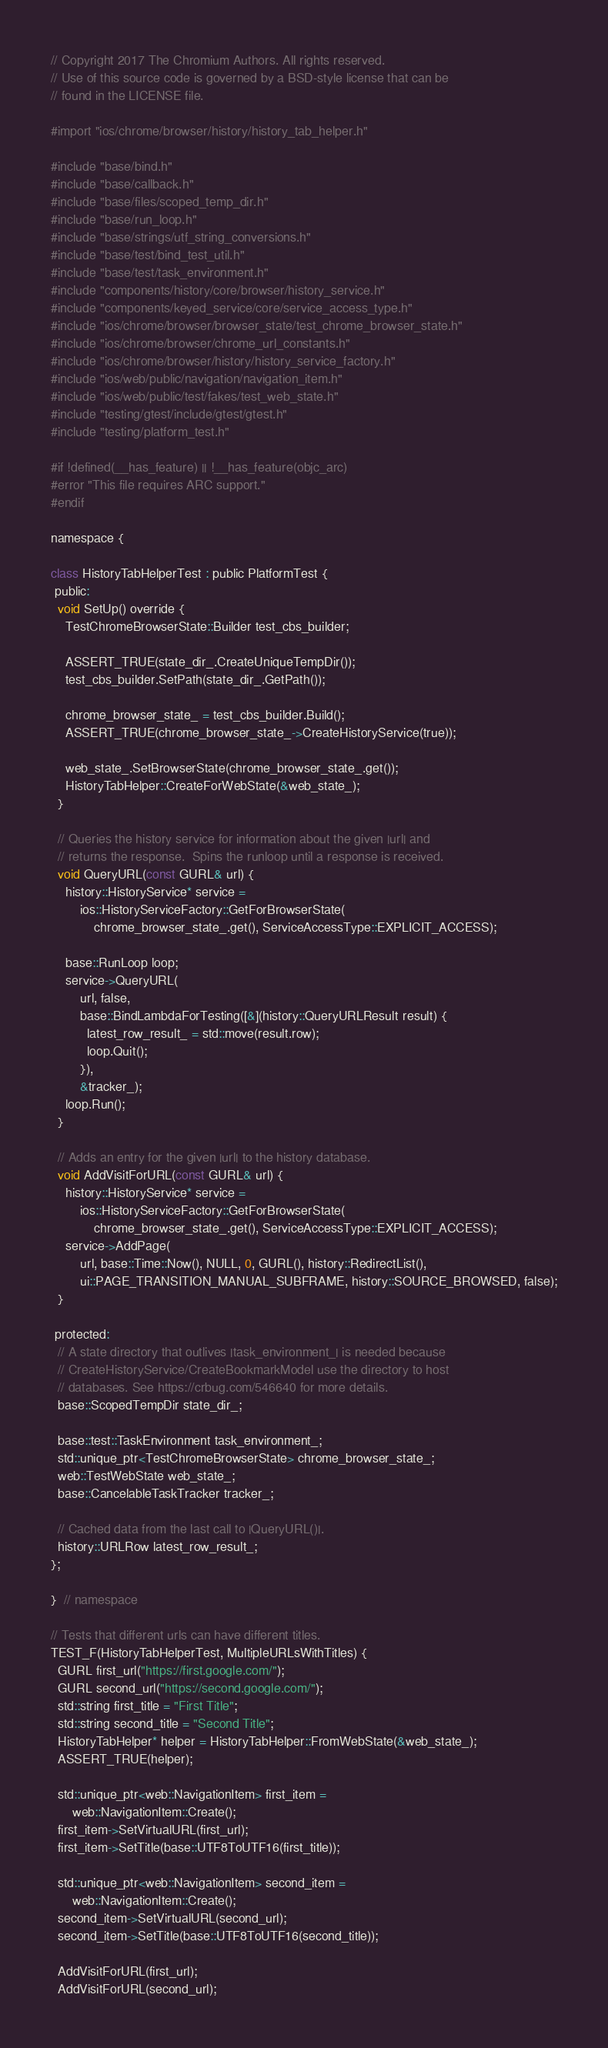<code> <loc_0><loc_0><loc_500><loc_500><_ObjectiveC_>// Copyright 2017 The Chromium Authors. All rights reserved.
// Use of this source code is governed by a BSD-style license that can be
// found in the LICENSE file.

#import "ios/chrome/browser/history/history_tab_helper.h"

#include "base/bind.h"
#include "base/callback.h"
#include "base/files/scoped_temp_dir.h"
#include "base/run_loop.h"
#include "base/strings/utf_string_conversions.h"
#include "base/test/bind_test_util.h"
#include "base/test/task_environment.h"
#include "components/history/core/browser/history_service.h"
#include "components/keyed_service/core/service_access_type.h"
#include "ios/chrome/browser/browser_state/test_chrome_browser_state.h"
#include "ios/chrome/browser/chrome_url_constants.h"
#include "ios/chrome/browser/history/history_service_factory.h"
#include "ios/web/public/navigation/navigation_item.h"
#include "ios/web/public/test/fakes/test_web_state.h"
#include "testing/gtest/include/gtest/gtest.h"
#include "testing/platform_test.h"

#if !defined(__has_feature) || !__has_feature(objc_arc)
#error "This file requires ARC support."
#endif

namespace {

class HistoryTabHelperTest : public PlatformTest {
 public:
  void SetUp() override {
    TestChromeBrowserState::Builder test_cbs_builder;

    ASSERT_TRUE(state_dir_.CreateUniqueTempDir());
    test_cbs_builder.SetPath(state_dir_.GetPath());

    chrome_browser_state_ = test_cbs_builder.Build();
    ASSERT_TRUE(chrome_browser_state_->CreateHistoryService(true));

    web_state_.SetBrowserState(chrome_browser_state_.get());
    HistoryTabHelper::CreateForWebState(&web_state_);
  }

  // Queries the history service for information about the given |url| and
  // returns the response.  Spins the runloop until a response is received.
  void QueryURL(const GURL& url) {
    history::HistoryService* service =
        ios::HistoryServiceFactory::GetForBrowserState(
            chrome_browser_state_.get(), ServiceAccessType::EXPLICIT_ACCESS);

    base::RunLoop loop;
    service->QueryURL(
        url, false,
        base::BindLambdaForTesting([&](history::QueryURLResult result) {
          latest_row_result_ = std::move(result.row);
          loop.Quit();
        }),
        &tracker_);
    loop.Run();
  }

  // Adds an entry for the given |url| to the history database.
  void AddVisitForURL(const GURL& url) {
    history::HistoryService* service =
        ios::HistoryServiceFactory::GetForBrowserState(
            chrome_browser_state_.get(), ServiceAccessType::EXPLICIT_ACCESS);
    service->AddPage(
        url, base::Time::Now(), NULL, 0, GURL(), history::RedirectList(),
        ui::PAGE_TRANSITION_MANUAL_SUBFRAME, history::SOURCE_BROWSED, false);
  }

 protected:
  // A state directory that outlives |task_environment_| is needed because
  // CreateHistoryService/CreateBookmarkModel use the directory to host
  // databases. See https://crbug.com/546640 for more details.
  base::ScopedTempDir state_dir_;

  base::test::TaskEnvironment task_environment_;
  std::unique_ptr<TestChromeBrowserState> chrome_browser_state_;
  web::TestWebState web_state_;
  base::CancelableTaskTracker tracker_;

  // Cached data from the last call to |QueryURL()|.
  history::URLRow latest_row_result_;
};

}  // namespace

// Tests that different urls can have different titles.
TEST_F(HistoryTabHelperTest, MultipleURLsWithTitles) {
  GURL first_url("https://first.google.com/");
  GURL second_url("https://second.google.com/");
  std::string first_title = "First Title";
  std::string second_title = "Second Title";
  HistoryTabHelper* helper = HistoryTabHelper::FromWebState(&web_state_);
  ASSERT_TRUE(helper);

  std::unique_ptr<web::NavigationItem> first_item =
      web::NavigationItem::Create();
  first_item->SetVirtualURL(first_url);
  first_item->SetTitle(base::UTF8ToUTF16(first_title));

  std::unique_ptr<web::NavigationItem> second_item =
      web::NavigationItem::Create();
  second_item->SetVirtualURL(second_url);
  second_item->SetTitle(base::UTF8ToUTF16(second_title));

  AddVisitForURL(first_url);
  AddVisitForURL(second_url);</code> 